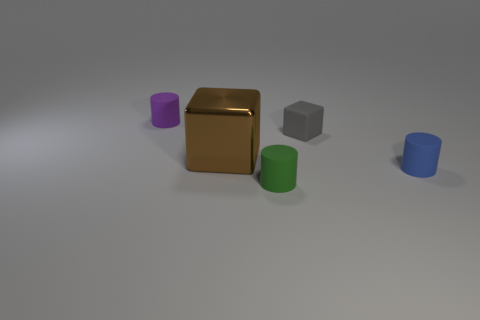Subtract all brown cylinders. Subtract all blue cubes. How many cylinders are left? 3 Add 1 tiny gray objects. How many objects exist? 6 Subtract all blocks. How many objects are left? 3 Subtract 0 red balls. How many objects are left? 5 Subtract all purple rubber things. Subtract all blue matte cylinders. How many objects are left? 3 Add 5 gray rubber cubes. How many gray rubber cubes are left? 6 Add 5 large gray matte objects. How many large gray matte objects exist? 5 